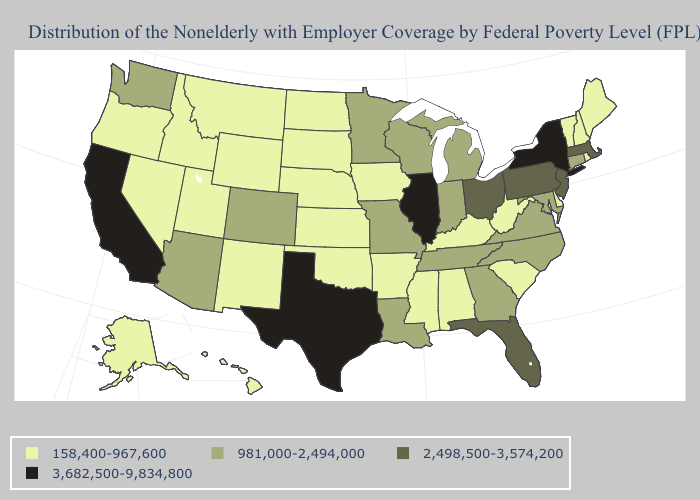Does Idaho have a higher value than Arkansas?
Keep it brief. No. Among the states that border Louisiana , does Mississippi have the lowest value?
Write a very short answer. Yes. Is the legend a continuous bar?
Quick response, please. No. Which states hav the highest value in the West?
Give a very brief answer. California. Which states have the highest value in the USA?
Write a very short answer. California, Illinois, New York, Texas. What is the lowest value in the USA?
Give a very brief answer. 158,400-967,600. What is the value of Arkansas?
Quick response, please. 158,400-967,600. Among the states that border Texas , does Louisiana have the highest value?
Write a very short answer. Yes. Does Indiana have a lower value than Florida?
Give a very brief answer. Yes. What is the value of Oregon?
Quick response, please. 158,400-967,600. What is the highest value in the South ?
Write a very short answer. 3,682,500-9,834,800. Does Pennsylvania have the lowest value in the Northeast?
Keep it brief. No. What is the highest value in states that border Montana?
Quick response, please. 158,400-967,600. What is the value of Kansas?
Answer briefly. 158,400-967,600. Among the states that border Indiana , which have the highest value?
Short answer required. Illinois. 